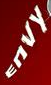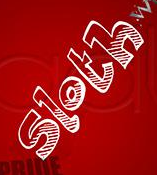Transcribe the words shown in these images in order, separated by a semicolon. ENVY; sloth 